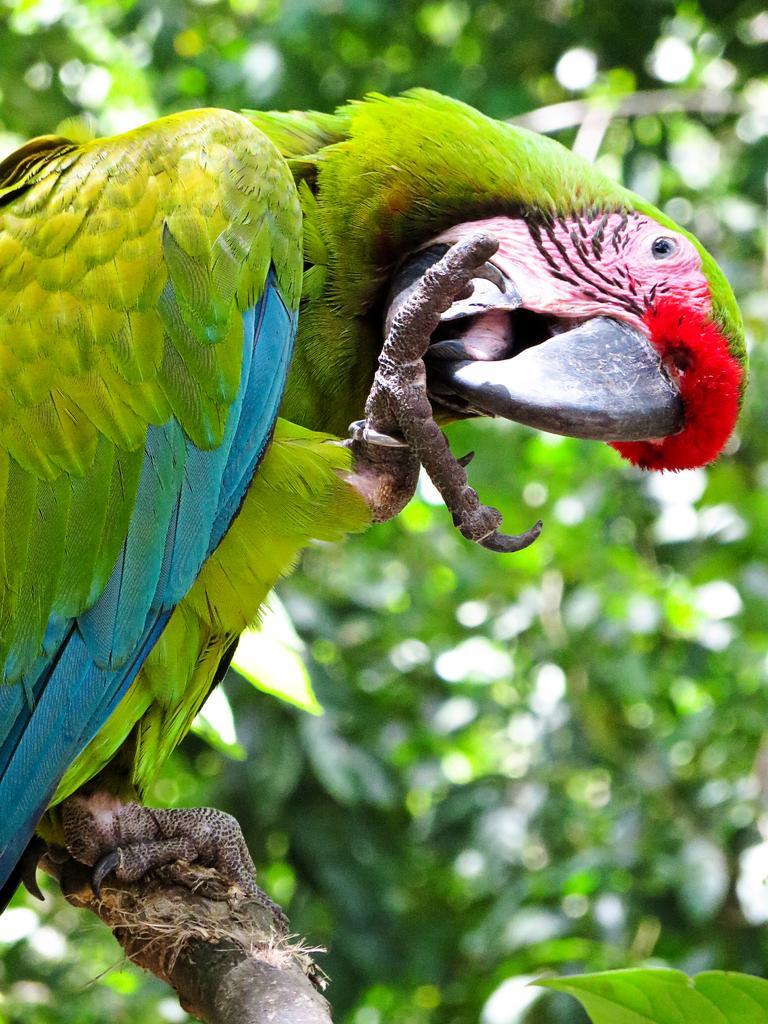In one or two sentences, can you explain what this image depicts? In this image, we can see a parrot on blur background. There is a leaf in the bottom right of the image. 